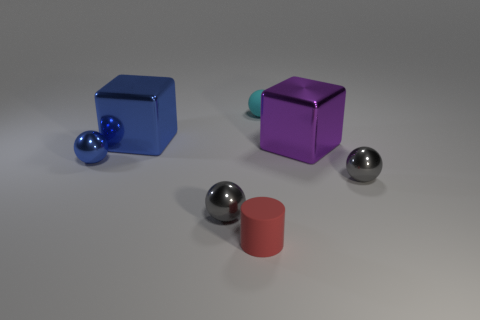Can you describe the colors of the objects in this image? Certainly! There are two cubes, one is blue and the other is purple. There are also three spheres: two are gray and one is blue, matching the color of the blue cube. Lastly, there's a cylindrical shape that has a matte red color. 